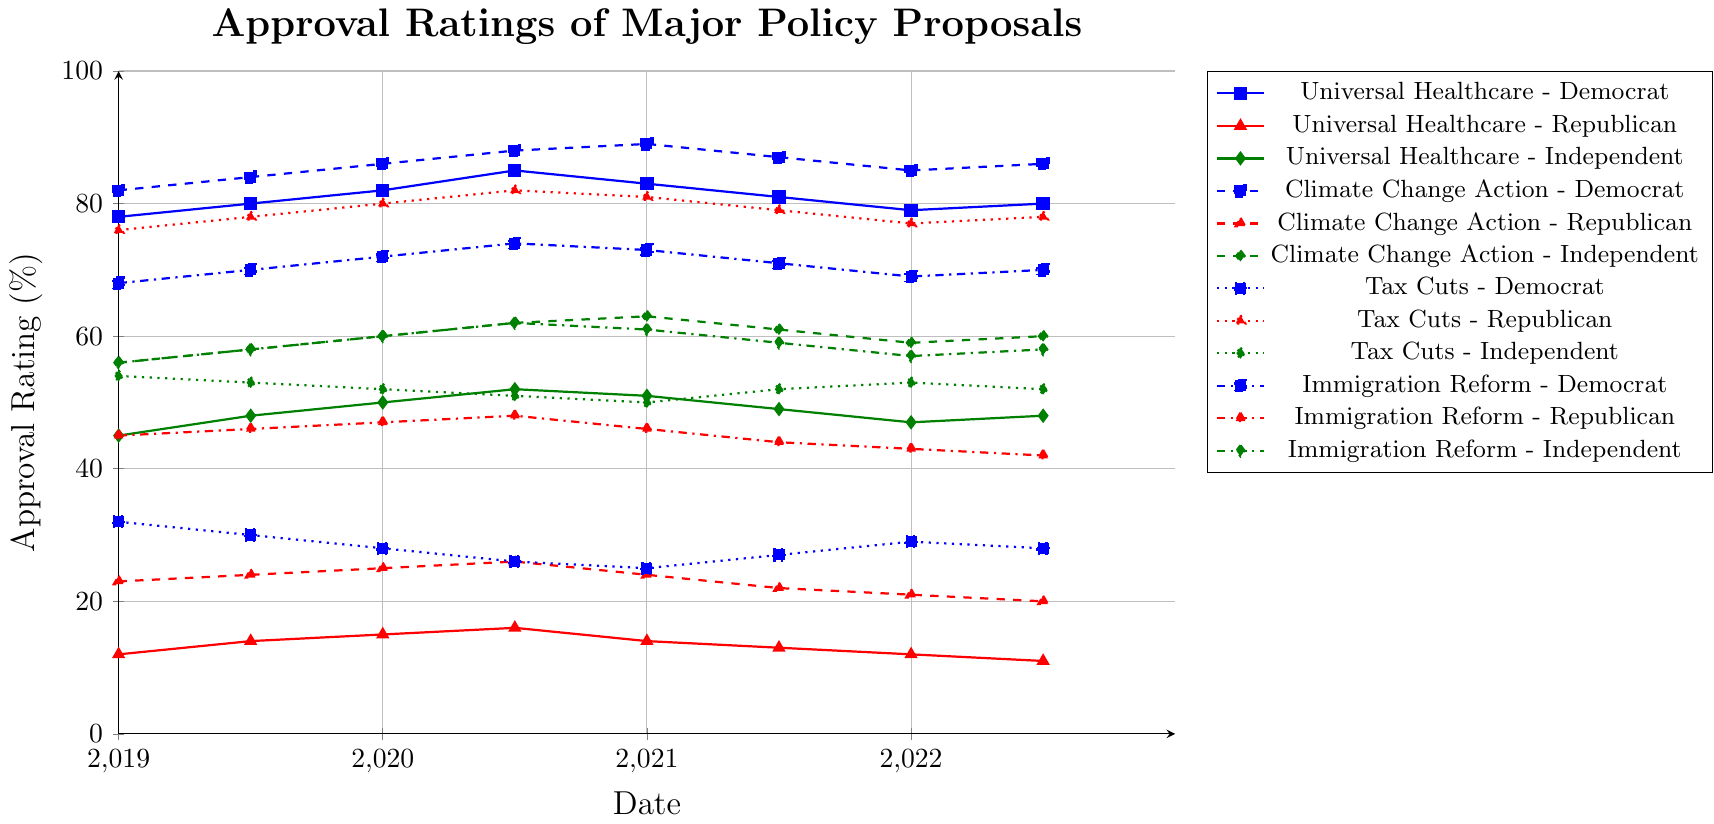Which policy proposal has the highest approval rating among Democrats in July 2021? First, find the date July 2021. Then check the chart for Democrats' approval ratings on that date. Climate Change Action has the highest approval rating (87%) among the other policy proposals.
Answer: Climate Change Action How did approval ratings for Universal Healthcare change for Republicans from January 2019 to July 2022? For Universal Healthcare, look at the values for Republicans: it started at 12% in January 2019 and decreased to 11% in July 2022. This shows a decline of 1%.
Answer: Decreased by 1% Which political affiliation consistently showed high approval ratings for Tax Cuts? Observe the Tax Cuts approval ratings across different affiliations. Republicans consistently showed high approval ratings, remaining above 75%.
Answer: Republican Between Immigration Reform and Universal Healthcare, which proposal had higher approval ratings among Independents in January 2020? For January 2020, compare the approval ratings of Immigration Reform (60%) and Universal Healthcare (50%) among Independents. Immigration Reform had higher ratings.
Answer: Immigration Reform What is the trend in approval ratings for Climate Change Action among Independents from 2019 to 2022? Observe the line for Climate Change Action among Independents. The approval ratings start at 56% in January 2019 and increase to 60% by July 2022, with a peak at 63% in January 2021. The overall trend shows an increase.
Answer: Increasing trend Among Democrats, which policy proposal saw the greatest decrease in approval ratings from January 2021 to July 2022? Compare approval ratings in January 2021 and July 2022 for all policy proposals among Democrats. Universal Healthcare had the greatest decrease from 83% to 80% (a drop of 3%).
Answer: Universal Healthcare Which policy proposal had the most stable approval ratings among Republicans over the given period? Look at the approval ratings for all policy proposals among Republicans. Tax Cuts had relatively stable ratings, fluctuating minimally around 76%-82%.
Answer: Tax Cuts For Independents, which policy proposal had the highest average approval rating between 2019 and 2022? Calculate the average approval ratings for all policy proposals among Independents. Climate Change Action had approval ratings of 56, 58, 60, 62, 63, 61, 59, and 60, which average to 59.88%.
Answer: Climate Change Action 